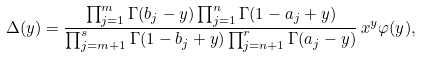Convert formula to latex. <formula><loc_0><loc_0><loc_500><loc_500>\Delta ( y ) = \frac { \prod _ { j = 1 } ^ { m } \Gamma ( b _ { j } - y ) \prod _ { j = 1 } ^ { n } \Gamma ( 1 - a _ { j } + y ) } { \prod _ { j = m + 1 } ^ { s } \Gamma ( 1 - b _ { j } + y ) \prod _ { j = n + 1 } ^ { r } \Gamma ( a _ { j } - y ) } \, x ^ { y } \varphi ( y ) ,</formula> 